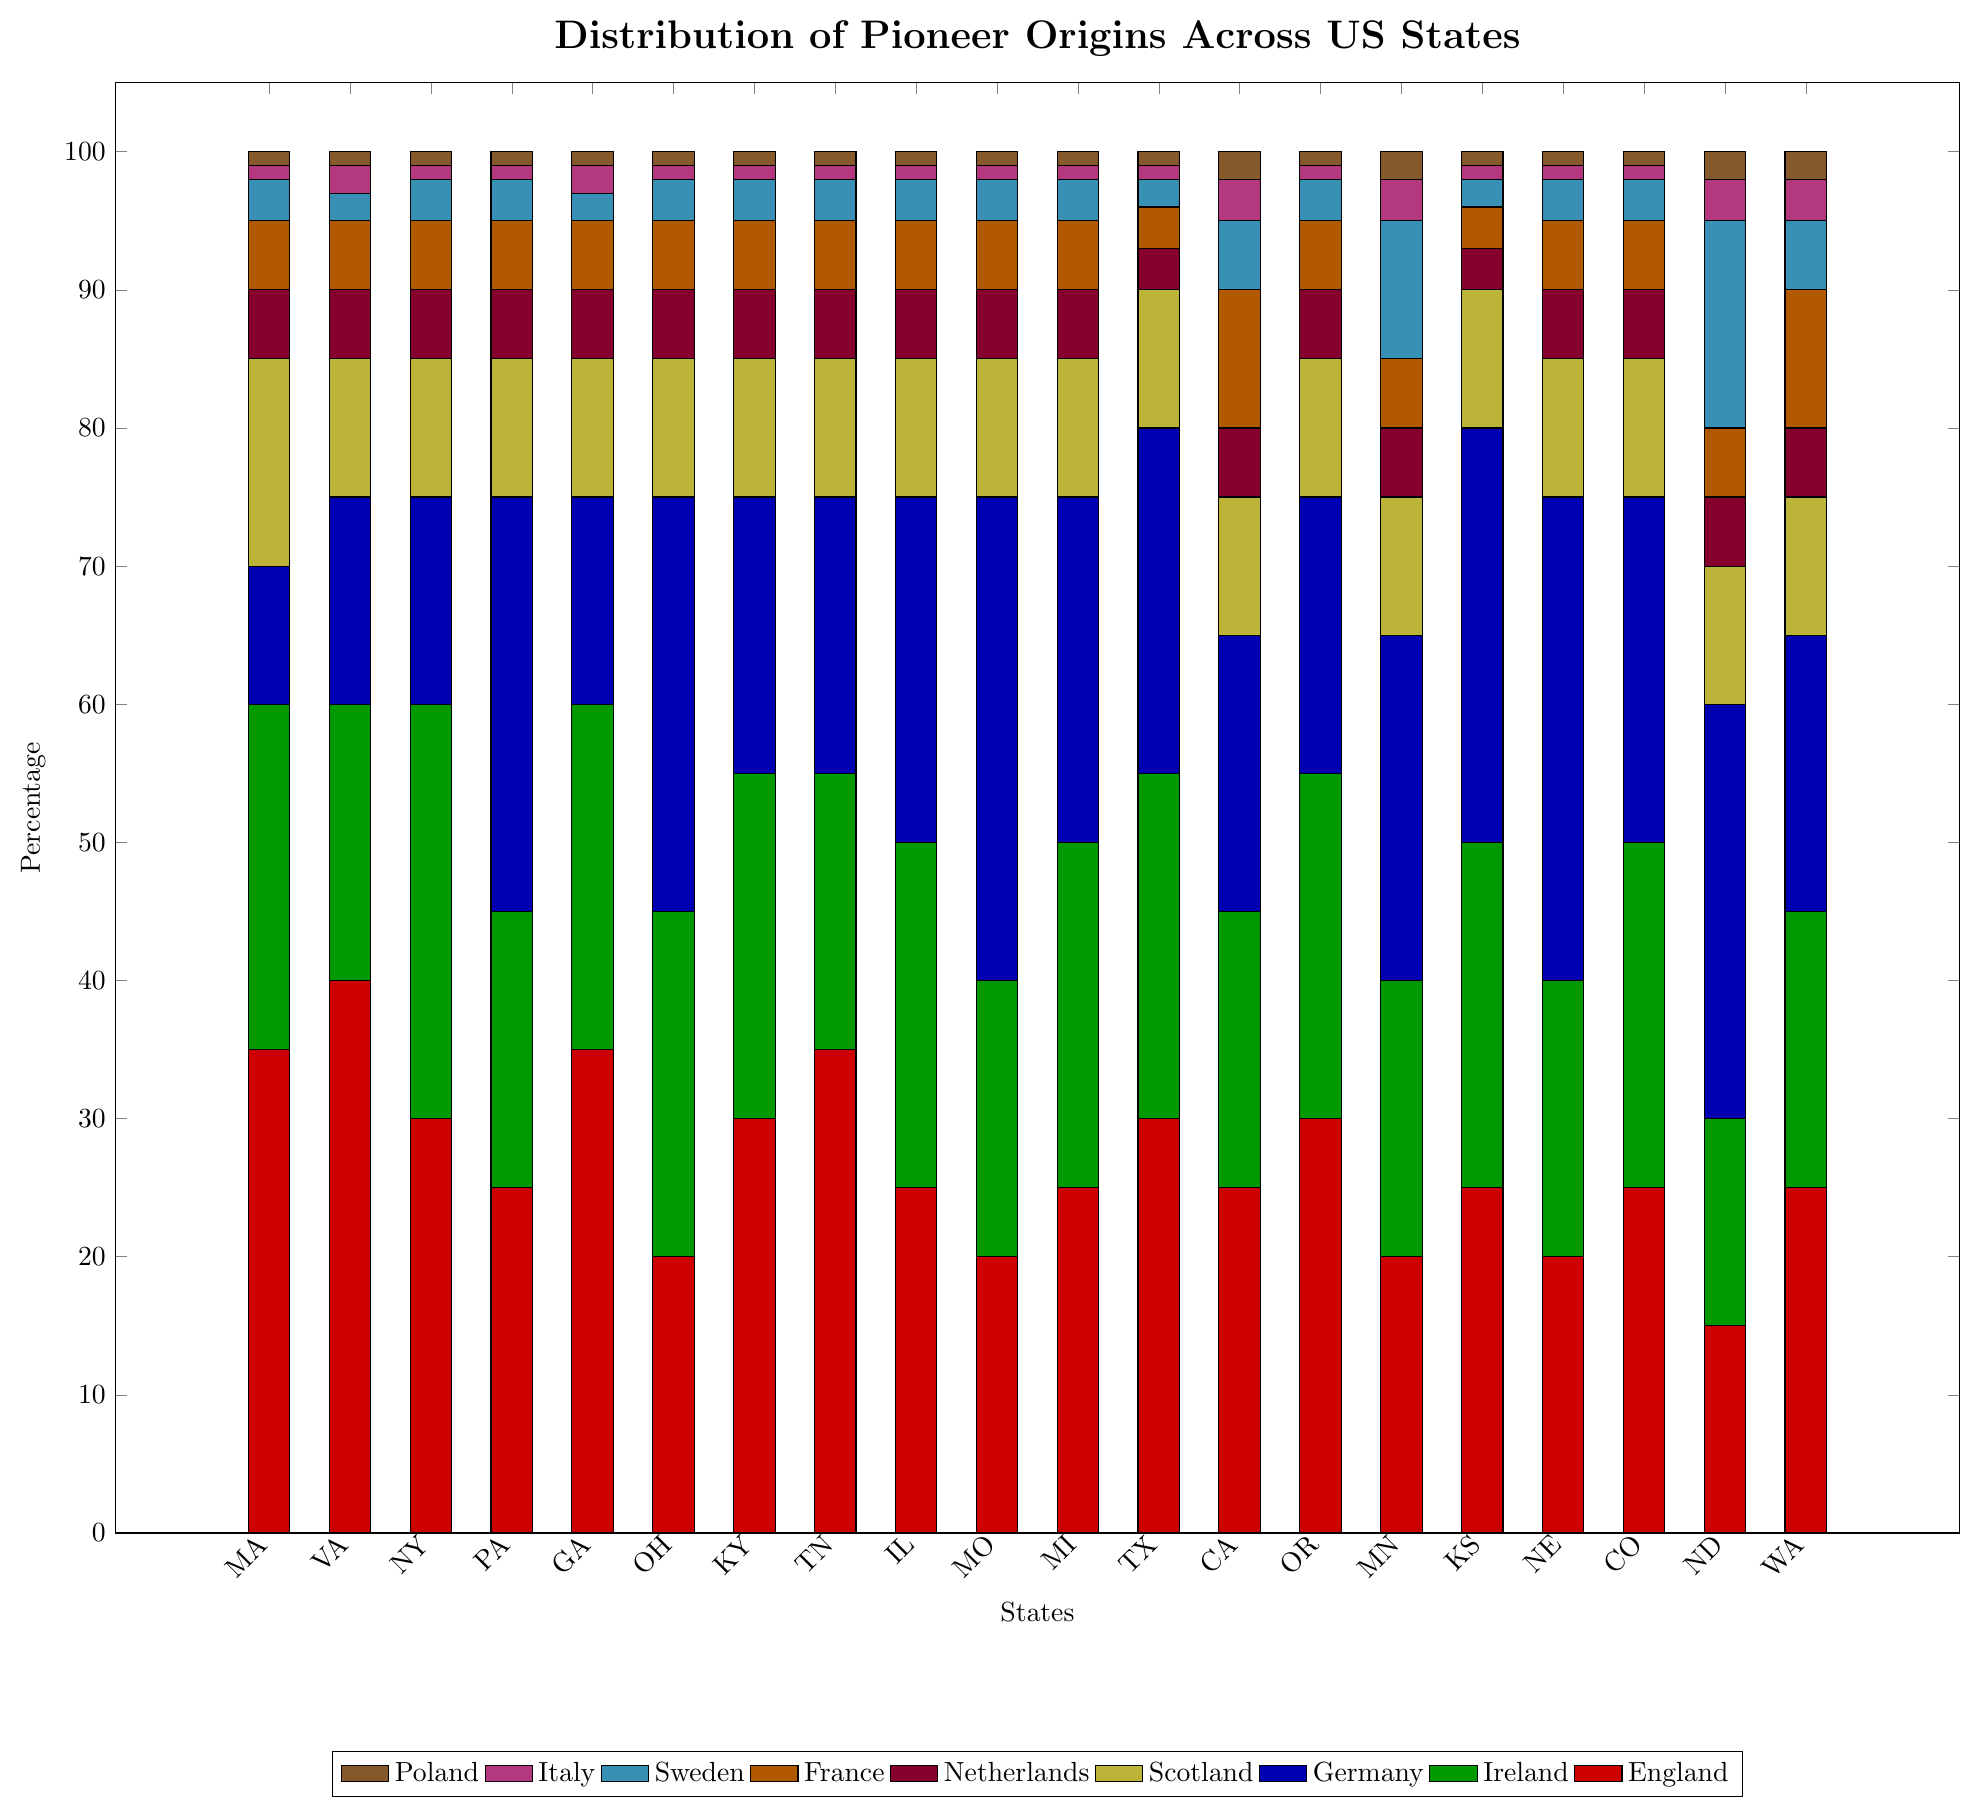Which state has the highest percentage of pioneers from Germany? By examining the height of the blue bars representing Germany, Missouri and Nebraska have the tallest, both at 35% each compared to other states.
Answer: Missouri and Nebraska Which state has the lowest percentage of pioneers from Poland? Referring to the height of the brown bars representing Poland, every state except California (2%) and Minnesota (2%) features a value of 1% or 2%. Still, Massachusetts, Pennsylvania, New York, Georgia, Ohio, Kentucky, Tennessee, Illinois, Missouri, Michigan, Texas, Oregon, Kansas, Nebraska, Colorado, and North Dakota all have the lowest percentage at 1%.
Answer: Massachusetts, Pennsylvania, New York, Georgia, Ohio, Kentucky, Tennessee, Illinois, Missouri, Michigan, Texas, Oregon, Kansas, Nebraska, Colorado, North Dakota What's the combined percentage of pioneers from France in California and Washington? To find the combined percentage, look at the orange bars for California and Washington. California has 10% and Washington has 10%, so their sum is 10% + 10% = 20%.
Answer: 20% In which states does the percentage of pioneers from England exceed 30%? Check the red bars to see that Massachusetts (35%), Virginia (40%), Georgia (35%), Tennessee (35%), and Texas (30%) all exceed or equal a percentage of 30%.
Answer: Massachusetts, Virginia, Georgia, Tennessee, Texas Which state has the highest combined percentage from Ireland and Sweden? To find the highest combined percentage, sum up the green and cyan bars for each state. The highest combined value is in North Dakota with (15% (Ireland) + 15% (Sweden)) = 30%.
Answer: North Dakota Which state has a higher percentage of pioneers from Sweden: California or Minnesota? Check the cyan bars for both states; California has 5% and Minnesota has 10%. Hence, Minnesota has a higher percentage from Sweden.
Answer: Minnesota Which states have an equal percentage of pioneers from Scotland? Evaluate the yellow bars for equality; they all have the same percentage of 10%.
Answer: All states For Virginia, what is the difference in percentage between pioneers from England and pioneers from Italy? Looking at the heights of red and magenta bars for Virginia; pioneers from England are 40%, and from Italy are 2%. The difference is 40% - 2% = 38%.
Answer: 38% What's the average percentage of pioneers from the Netherlands across all states? Sum the purple bars: (5 + 5 + 5 + 5 + 5 + 5 + 5 + 5 + 5 + 5 + 5 + 3 + 5 + 5 + 5 + 3 + 5 + 5 + 5 + 5) = 101. There are 20 states, so the average is 101 / 20 = 5.05%.
Answer: 5.05% 